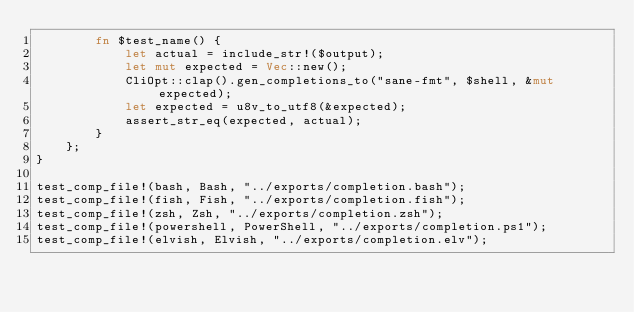Convert code to text. <code><loc_0><loc_0><loc_500><loc_500><_Rust_>        fn $test_name() {
            let actual = include_str!($output);
            let mut expected = Vec::new();
            CliOpt::clap().gen_completions_to("sane-fmt", $shell, &mut expected);
            let expected = u8v_to_utf8(&expected);
            assert_str_eq(expected, actual);
        }
    };
}

test_comp_file!(bash, Bash, "../exports/completion.bash");
test_comp_file!(fish, Fish, "../exports/completion.fish");
test_comp_file!(zsh, Zsh, "../exports/completion.zsh");
test_comp_file!(powershell, PowerShell, "../exports/completion.ps1");
test_comp_file!(elvish, Elvish, "../exports/completion.elv");
</code> 